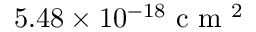<formula> <loc_0><loc_0><loc_500><loc_500>5 . 4 8 \times 1 0 ^ { - 1 8 } c m ^ { 2 }</formula> 